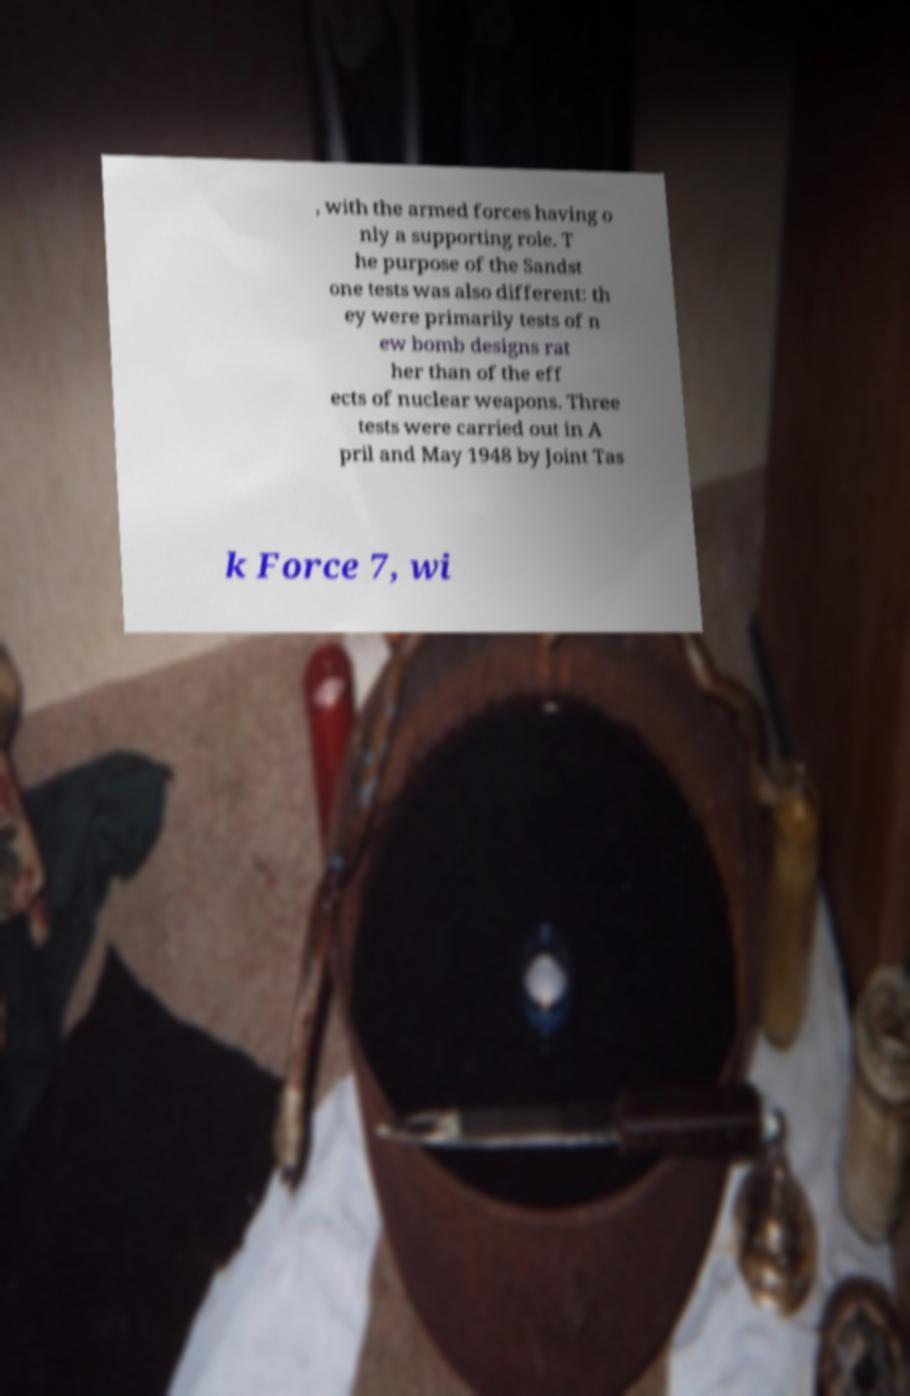What messages or text are displayed in this image? I need them in a readable, typed format. , with the armed forces having o nly a supporting role. T he purpose of the Sandst one tests was also different: th ey were primarily tests of n ew bomb designs rat her than of the eff ects of nuclear weapons. Three tests were carried out in A pril and May 1948 by Joint Tas k Force 7, wi 